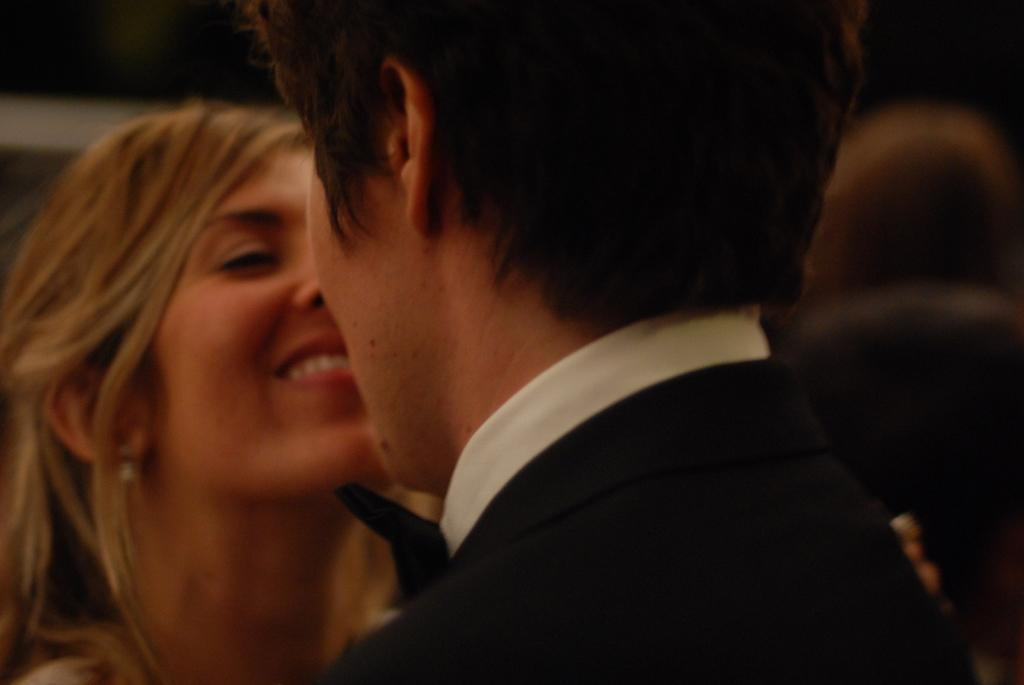How many people are in the image? There are two persons in the foreground of the image. What can be observed about the background of the image? The background of the image is blurry. Are there any objects visible in the background? Yes, there are some objects in the background of the image. What type of jewel is being worn by the person in the image? There is no visible jewelry on the persons in the image, so it cannot be determined what type of jewel might be worn. 